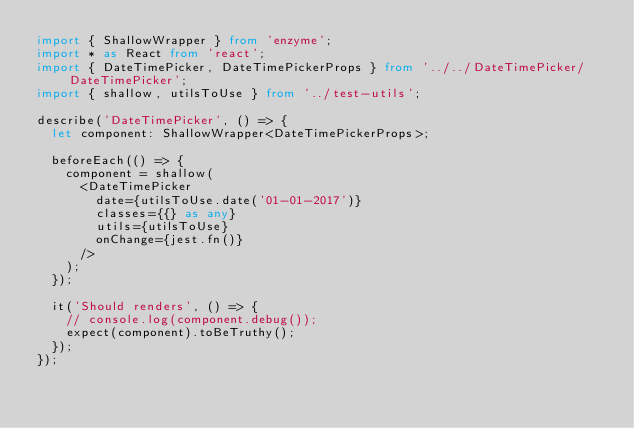<code> <loc_0><loc_0><loc_500><loc_500><_TypeScript_>import { ShallowWrapper } from 'enzyme';
import * as React from 'react';
import { DateTimePicker, DateTimePickerProps } from '../../DateTimePicker/DateTimePicker';
import { shallow, utilsToUse } from '../test-utils';

describe('DateTimePicker', () => {
  let component: ShallowWrapper<DateTimePickerProps>;

  beforeEach(() => {
    component = shallow(
      <DateTimePicker
        date={utilsToUse.date('01-01-2017')}
        classes={{} as any}
        utils={utilsToUse}
        onChange={jest.fn()}
      />
    );
  });

  it('Should renders', () => {
    // console.log(component.debug());
    expect(component).toBeTruthy();
  });
});
</code> 